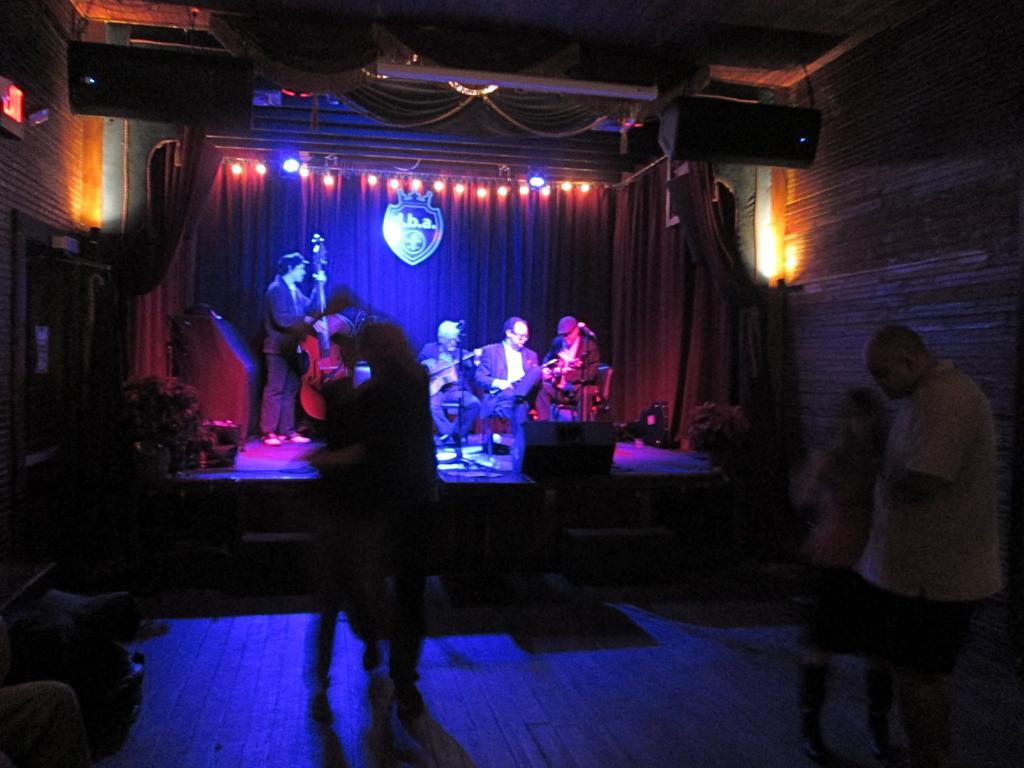Can you describe this image briefly? In this image there are group of persons standing in the center. In the background there are persons sitting and standing and on the left side there is a person holding a musical instrument in his hand, there is a curtain in the background and there are lights on the top. On the left side there is a plant and on the right side there is a wall and in front of the wall there is a plant and there is an object which is black and red in colour. On the top there are speakers. 